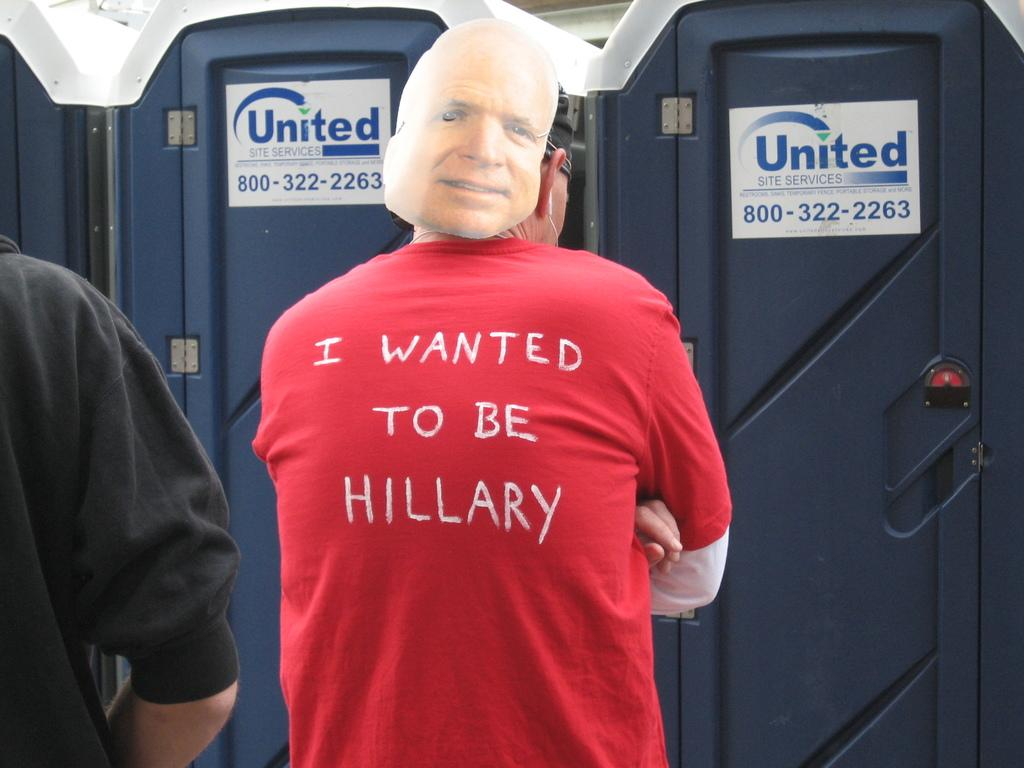<image>
Create a compact narrative representing the image presented. A man stands in front of United mobile restrooms wearing a shirt that says "I wanted to be Hillary." 